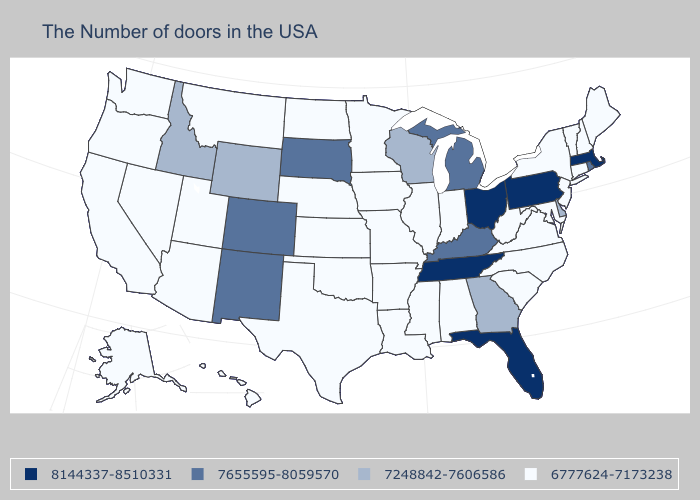Among the states that border New York , does Massachusetts have the lowest value?
Write a very short answer. No. Which states have the lowest value in the USA?
Quick response, please. Maine, New Hampshire, Vermont, Connecticut, New York, New Jersey, Maryland, Virginia, North Carolina, South Carolina, West Virginia, Indiana, Alabama, Illinois, Mississippi, Louisiana, Missouri, Arkansas, Minnesota, Iowa, Kansas, Nebraska, Oklahoma, Texas, North Dakota, Utah, Montana, Arizona, Nevada, California, Washington, Oregon, Alaska, Hawaii. Does New Jersey have the lowest value in the Northeast?
Keep it brief. Yes. What is the value of Mississippi?
Give a very brief answer. 6777624-7173238. What is the value of Delaware?
Keep it brief. 7248842-7606586. Does New Mexico have the highest value in the West?
Keep it brief. Yes. Does the map have missing data?
Answer briefly. No. Name the states that have a value in the range 8144337-8510331?
Keep it brief. Massachusetts, Pennsylvania, Ohio, Florida, Tennessee. What is the value of Massachusetts?
Be succinct. 8144337-8510331. What is the value of Colorado?
Concise answer only. 7655595-8059570. Does Maine have the highest value in the USA?
Concise answer only. No. Which states have the lowest value in the MidWest?
Give a very brief answer. Indiana, Illinois, Missouri, Minnesota, Iowa, Kansas, Nebraska, North Dakota. Does Missouri have the highest value in the MidWest?
Give a very brief answer. No. 